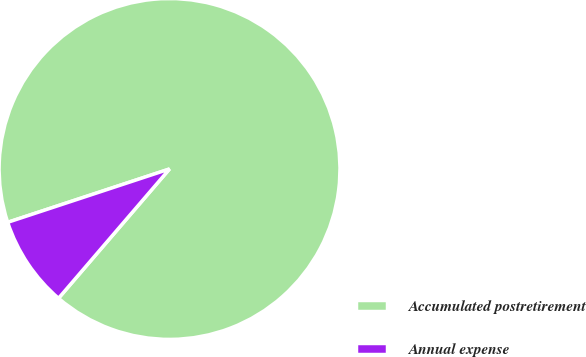Convert chart. <chart><loc_0><loc_0><loc_500><loc_500><pie_chart><fcel>Accumulated postretirement<fcel>Annual expense<nl><fcel>91.36%<fcel>8.64%<nl></chart> 